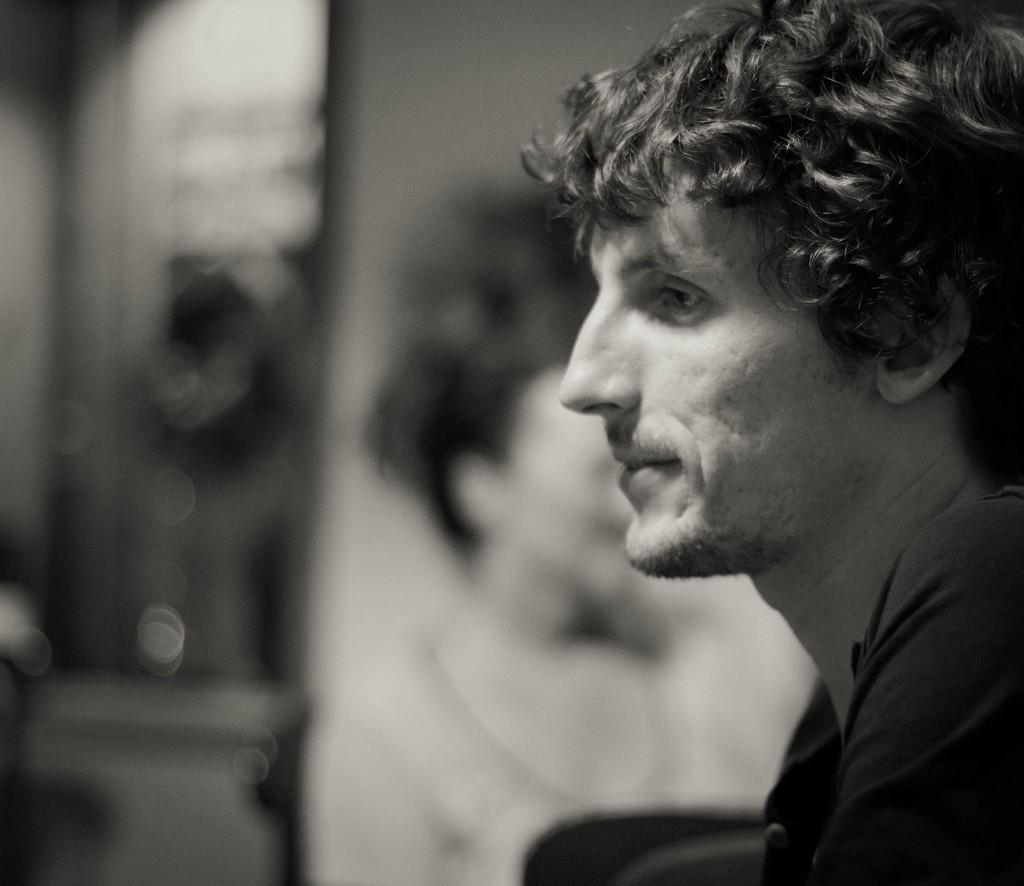Please provide a concise description of this image. In this picture I can see a man and looks like a woman beside him. 